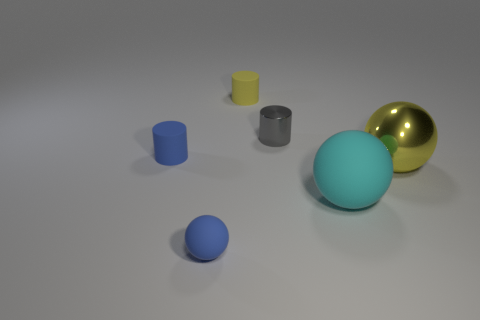What color is the ball that is the same size as the blue cylinder?
Ensure brevity in your answer.  Blue. What number of matte objects are in front of the tiny rubber cylinder that is behind the gray object?
Your response must be concise. 3. What number of objects are tiny blue things in front of the large yellow thing or large green cylinders?
Your answer should be very brief. 1. What number of other yellow cylinders have the same material as the yellow cylinder?
Your answer should be compact. 0. What is the shape of the object that is the same color as the tiny sphere?
Offer a terse response. Cylinder. Are there an equal number of cylinders that are in front of the cyan matte ball and tiny yellow spheres?
Offer a terse response. Yes. There is a metallic thing in front of the blue cylinder; what size is it?
Ensure brevity in your answer.  Large. How many large objects are either red rubber balls or gray objects?
Keep it short and to the point. 0. What color is the metallic object that is the same shape as the cyan matte object?
Your answer should be very brief. Yellow. Does the yellow shiny thing have the same size as the shiny cylinder?
Your answer should be very brief. No. 